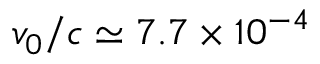Convert formula to latex. <formula><loc_0><loc_0><loc_500><loc_500>v _ { 0 } / c \simeq 7 . 7 \times 1 0 ^ { - 4 }</formula> 